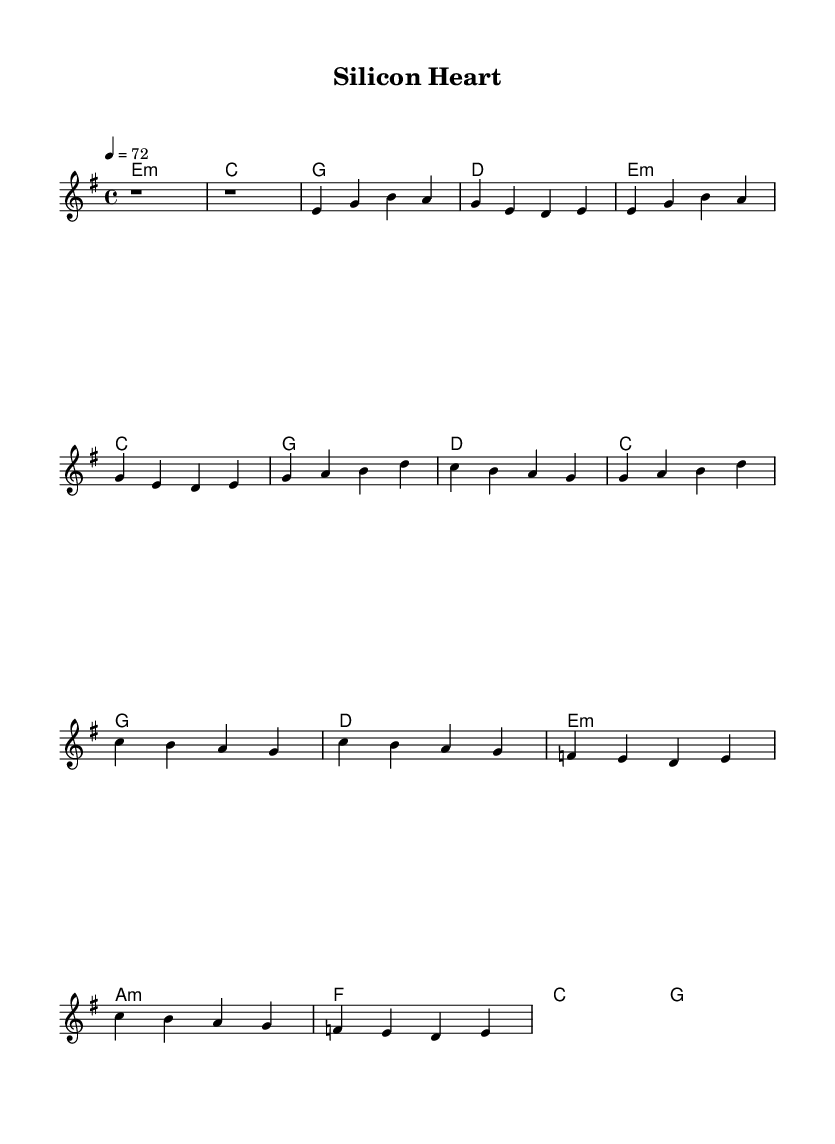What is the key signature of this music? The key signature is indicated by the key signature symbol on the left side of the staff, which shows that it is in E minor (one sharp).
Answer: E minor What is the time signature of this piece? The time signature is shown at the beginning of the staff, which states that it is in four beats per measure with the quarter note receiving one beat.
Answer: 4/4 What is the tempo marking for this piece? The tempo is indicated above the staff at the beginning, stating "4 = 72", which indicates that there are 72 beats per minute.
Answer: 72 How many sections are there in this piece? By analyzing the structure of the piece, it consists of an intro, verse, chorus, and bridge, making a total of four distinct sections.
Answer: Four What type of chords are predominantly used in the chorus? By reviewing the chord pattern in the chorus, it can be seen that the progression consists of major and minor chords, specifically emphasizing harmony.
Answer: Major and minor chords What is the first note of the melody? The first note of the melody is indicated in the relative notation at the start of the melody line, which shows that it begins with a rest.
Answer: Rest What is the overall mood conveyed by the harmonization choices? By looking at the selection of minor and major chords throughout the piece, the overall mood appears reflective and emotional, resonating well with the themes of alternative rock ballads that reflect on ethics in robotics.
Answer: Reflective and emotional 